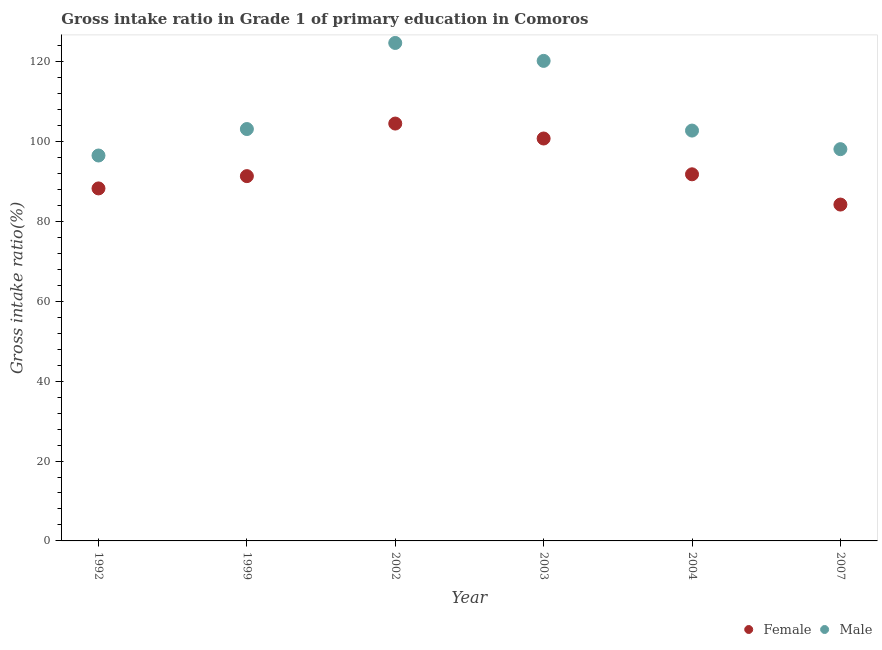What is the gross intake ratio(female) in 2007?
Provide a short and direct response. 84.2. Across all years, what is the maximum gross intake ratio(female)?
Provide a succinct answer. 104.48. Across all years, what is the minimum gross intake ratio(male)?
Give a very brief answer. 96.48. In which year was the gross intake ratio(male) maximum?
Your answer should be compact. 2002. In which year was the gross intake ratio(female) minimum?
Offer a terse response. 2007. What is the total gross intake ratio(female) in the graph?
Keep it short and to the point. 560.77. What is the difference between the gross intake ratio(female) in 2002 and that in 2004?
Provide a short and direct response. 12.7. What is the difference between the gross intake ratio(male) in 1999 and the gross intake ratio(female) in 2004?
Offer a very short reply. 11.33. What is the average gross intake ratio(male) per year?
Provide a succinct answer. 107.54. In the year 2004, what is the difference between the gross intake ratio(male) and gross intake ratio(female)?
Provide a succinct answer. 10.95. In how many years, is the gross intake ratio(female) greater than 72 %?
Keep it short and to the point. 6. What is the ratio of the gross intake ratio(female) in 1999 to that in 2004?
Make the answer very short. 1. Is the gross intake ratio(male) in 2002 less than that in 2007?
Your answer should be very brief. No. Is the difference between the gross intake ratio(female) in 2002 and 2003 greater than the difference between the gross intake ratio(male) in 2002 and 2003?
Offer a terse response. No. What is the difference between the highest and the second highest gross intake ratio(male)?
Your response must be concise. 4.49. What is the difference between the highest and the lowest gross intake ratio(male)?
Offer a terse response. 28.18. In how many years, is the gross intake ratio(female) greater than the average gross intake ratio(female) taken over all years?
Ensure brevity in your answer.  2. Is the sum of the gross intake ratio(female) in 1999 and 2007 greater than the maximum gross intake ratio(male) across all years?
Provide a succinct answer. Yes. Is the gross intake ratio(female) strictly greater than the gross intake ratio(male) over the years?
Your answer should be very brief. No. Is the gross intake ratio(male) strictly less than the gross intake ratio(female) over the years?
Keep it short and to the point. No. What is the difference between two consecutive major ticks on the Y-axis?
Your answer should be very brief. 20. Are the values on the major ticks of Y-axis written in scientific E-notation?
Provide a short and direct response. No. What is the title of the graph?
Provide a succinct answer. Gross intake ratio in Grade 1 of primary education in Comoros. Does "Primary" appear as one of the legend labels in the graph?
Your response must be concise. No. What is the label or title of the Y-axis?
Give a very brief answer. Gross intake ratio(%). What is the Gross intake ratio(%) of Female in 1992?
Your response must be concise. 88.25. What is the Gross intake ratio(%) of Male in 1992?
Your answer should be very brief. 96.48. What is the Gross intake ratio(%) in Female in 1999?
Make the answer very short. 91.32. What is the Gross intake ratio(%) in Male in 1999?
Your answer should be compact. 103.11. What is the Gross intake ratio(%) in Female in 2002?
Ensure brevity in your answer.  104.48. What is the Gross intake ratio(%) of Male in 2002?
Your answer should be very brief. 124.66. What is the Gross intake ratio(%) of Female in 2003?
Your response must be concise. 100.74. What is the Gross intake ratio(%) in Male in 2003?
Offer a very short reply. 120.17. What is the Gross intake ratio(%) of Female in 2004?
Make the answer very short. 91.78. What is the Gross intake ratio(%) of Male in 2004?
Provide a succinct answer. 102.73. What is the Gross intake ratio(%) of Female in 2007?
Your answer should be compact. 84.2. What is the Gross intake ratio(%) of Male in 2007?
Your answer should be compact. 98.07. Across all years, what is the maximum Gross intake ratio(%) of Female?
Provide a succinct answer. 104.48. Across all years, what is the maximum Gross intake ratio(%) in Male?
Your answer should be very brief. 124.66. Across all years, what is the minimum Gross intake ratio(%) in Female?
Offer a terse response. 84.2. Across all years, what is the minimum Gross intake ratio(%) in Male?
Your response must be concise. 96.48. What is the total Gross intake ratio(%) of Female in the graph?
Make the answer very short. 560.77. What is the total Gross intake ratio(%) of Male in the graph?
Your answer should be very brief. 645.23. What is the difference between the Gross intake ratio(%) of Female in 1992 and that in 1999?
Provide a short and direct response. -3.08. What is the difference between the Gross intake ratio(%) of Male in 1992 and that in 1999?
Offer a terse response. -6.63. What is the difference between the Gross intake ratio(%) in Female in 1992 and that in 2002?
Provide a succinct answer. -16.24. What is the difference between the Gross intake ratio(%) of Male in 1992 and that in 2002?
Your answer should be very brief. -28.18. What is the difference between the Gross intake ratio(%) in Female in 1992 and that in 2003?
Your answer should be compact. -12.49. What is the difference between the Gross intake ratio(%) of Male in 1992 and that in 2003?
Ensure brevity in your answer.  -23.69. What is the difference between the Gross intake ratio(%) in Female in 1992 and that in 2004?
Ensure brevity in your answer.  -3.53. What is the difference between the Gross intake ratio(%) in Male in 1992 and that in 2004?
Your answer should be very brief. -6.24. What is the difference between the Gross intake ratio(%) in Female in 1992 and that in 2007?
Your answer should be very brief. 4.04. What is the difference between the Gross intake ratio(%) in Male in 1992 and that in 2007?
Offer a very short reply. -1.59. What is the difference between the Gross intake ratio(%) of Female in 1999 and that in 2002?
Give a very brief answer. -13.16. What is the difference between the Gross intake ratio(%) of Male in 1999 and that in 2002?
Ensure brevity in your answer.  -21.55. What is the difference between the Gross intake ratio(%) in Female in 1999 and that in 2003?
Your response must be concise. -9.42. What is the difference between the Gross intake ratio(%) of Male in 1999 and that in 2003?
Ensure brevity in your answer.  -17.06. What is the difference between the Gross intake ratio(%) in Female in 1999 and that in 2004?
Ensure brevity in your answer.  -0.46. What is the difference between the Gross intake ratio(%) in Male in 1999 and that in 2004?
Ensure brevity in your answer.  0.38. What is the difference between the Gross intake ratio(%) of Female in 1999 and that in 2007?
Offer a terse response. 7.12. What is the difference between the Gross intake ratio(%) of Male in 1999 and that in 2007?
Offer a terse response. 5.04. What is the difference between the Gross intake ratio(%) of Female in 2002 and that in 2003?
Keep it short and to the point. 3.74. What is the difference between the Gross intake ratio(%) in Male in 2002 and that in 2003?
Make the answer very short. 4.49. What is the difference between the Gross intake ratio(%) in Female in 2002 and that in 2004?
Your response must be concise. 12.7. What is the difference between the Gross intake ratio(%) in Male in 2002 and that in 2004?
Offer a terse response. 21.93. What is the difference between the Gross intake ratio(%) of Female in 2002 and that in 2007?
Provide a short and direct response. 20.28. What is the difference between the Gross intake ratio(%) of Male in 2002 and that in 2007?
Your response must be concise. 26.59. What is the difference between the Gross intake ratio(%) of Female in 2003 and that in 2004?
Your answer should be compact. 8.96. What is the difference between the Gross intake ratio(%) of Male in 2003 and that in 2004?
Your answer should be compact. 17.45. What is the difference between the Gross intake ratio(%) of Female in 2003 and that in 2007?
Make the answer very short. 16.54. What is the difference between the Gross intake ratio(%) of Male in 2003 and that in 2007?
Your response must be concise. 22.1. What is the difference between the Gross intake ratio(%) in Female in 2004 and that in 2007?
Keep it short and to the point. 7.58. What is the difference between the Gross intake ratio(%) in Male in 2004 and that in 2007?
Ensure brevity in your answer.  4.65. What is the difference between the Gross intake ratio(%) of Female in 1992 and the Gross intake ratio(%) of Male in 1999?
Your answer should be compact. -14.86. What is the difference between the Gross intake ratio(%) in Female in 1992 and the Gross intake ratio(%) in Male in 2002?
Your answer should be compact. -36.42. What is the difference between the Gross intake ratio(%) of Female in 1992 and the Gross intake ratio(%) of Male in 2003?
Your response must be concise. -31.93. What is the difference between the Gross intake ratio(%) in Female in 1992 and the Gross intake ratio(%) in Male in 2004?
Give a very brief answer. -14.48. What is the difference between the Gross intake ratio(%) in Female in 1992 and the Gross intake ratio(%) in Male in 2007?
Your answer should be very brief. -9.83. What is the difference between the Gross intake ratio(%) in Female in 1999 and the Gross intake ratio(%) in Male in 2002?
Give a very brief answer. -33.34. What is the difference between the Gross intake ratio(%) of Female in 1999 and the Gross intake ratio(%) of Male in 2003?
Ensure brevity in your answer.  -28.85. What is the difference between the Gross intake ratio(%) of Female in 1999 and the Gross intake ratio(%) of Male in 2004?
Offer a terse response. -11.4. What is the difference between the Gross intake ratio(%) in Female in 1999 and the Gross intake ratio(%) in Male in 2007?
Keep it short and to the point. -6.75. What is the difference between the Gross intake ratio(%) in Female in 2002 and the Gross intake ratio(%) in Male in 2003?
Your answer should be very brief. -15.69. What is the difference between the Gross intake ratio(%) in Female in 2002 and the Gross intake ratio(%) in Male in 2004?
Make the answer very short. 1.76. What is the difference between the Gross intake ratio(%) in Female in 2002 and the Gross intake ratio(%) in Male in 2007?
Offer a very short reply. 6.41. What is the difference between the Gross intake ratio(%) in Female in 2003 and the Gross intake ratio(%) in Male in 2004?
Keep it short and to the point. -1.99. What is the difference between the Gross intake ratio(%) in Female in 2003 and the Gross intake ratio(%) in Male in 2007?
Offer a terse response. 2.67. What is the difference between the Gross intake ratio(%) in Female in 2004 and the Gross intake ratio(%) in Male in 2007?
Your response must be concise. -6.29. What is the average Gross intake ratio(%) in Female per year?
Provide a short and direct response. 93.46. What is the average Gross intake ratio(%) of Male per year?
Your answer should be compact. 107.54. In the year 1992, what is the difference between the Gross intake ratio(%) of Female and Gross intake ratio(%) of Male?
Offer a terse response. -8.24. In the year 1999, what is the difference between the Gross intake ratio(%) of Female and Gross intake ratio(%) of Male?
Ensure brevity in your answer.  -11.79. In the year 2002, what is the difference between the Gross intake ratio(%) in Female and Gross intake ratio(%) in Male?
Your answer should be compact. -20.18. In the year 2003, what is the difference between the Gross intake ratio(%) in Female and Gross intake ratio(%) in Male?
Provide a short and direct response. -19.43. In the year 2004, what is the difference between the Gross intake ratio(%) of Female and Gross intake ratio(%) of Male?
Offer a very short reply. -10.95. In the year 2007, what is the difference between the Gross intake ratio(%) of Female and Gross intake ratio(%) of Male?
Provide a short and direct response. -13.87. What is the ratio of the Gross intake ratio(%) of Female in 1992 to that in 1999?
Give a very brief answer. 0.97. What is the ratio of the Gross intake ratio(%) of Male in 1992 to that in 1999?
Offer a very short reply. 0.94. What is the ratio of the Gross intake ratio(%) of Female in 1992 to that in 2002?
Ensure brevity in your answer.  0.84. What is the ratio of the Gross intake ratio(%) of Male in 1992 to that in 2002?
Your answer should be very brief. 0.77. What is the ratio of the Gross intake ratio(%) in Female in 1992 to that in 2003?
Your answer should be compact. 0.88. What is the ratio of the Gross intake ratio(%) in Male in 1992 to that in 2003?
Offer a terse response. 0.8. What is the ratio of the Gross intake ratio(%) of Female in 1992 to that in 2004?
Offer a terse response. 0.96. What is the ratio of the Gross intake ratio(%) in Male in 1992 to that in 2004?
Keep it short and to the point. 0.94. What is the ratio of the Gross intake ratio(%) of Female in 1992 to that in 2007?
Your answer should be compact. 1.05. What is the ratio of the Gross intake ratio(%) in Male in 1992 to that in 2007?
Provide a short and direct response. 0.98. What is the ratio of the Gross intake ratio(%) of Female in 1999 to that in 2002?
Provide a short and direct response. 0.87. What is the ratio of the Gross intake ratio(%) in Male in 1999 to that in 2002?
Your response must be concise. 0.83. What is the ratio of the Gross intake ratio(%) of Female in 1999 to that in 2003?
Provide a short and direct response. 0.91. What is the ratio of the Gross intake ratio(%) in Male in 1999 to that in 2003?
Your response must be concise. 0.86. What is the ratio of the Gross intake ratio(%) of Female in 1999 to that in 2004?
Your answer should be very brief. 0.99. What is the ratio of the Gross intake ratio(%) in Male in 1999 to that in 2004?
Make the answer very short. 1. What is the ratio of the Gross intake ratio(%) of Female in 1999 to that in 2007?
Offer a very short reply. 1.08. What is the ratio of the Gross intake ratio(%) in Male in 1999 to that in 2007?
Ensure brevity in your answer.  1.05. What is the ratio of the Gross intake ratio(%) in Female in 2002 to that in 2003?
Keep it short and to the point. 1.04. What is the ratio of the Gross intake ratio(%) in Male in 2002 to that in 2003?
Offer a very short reply. 1.04. What is the ratio of the Gross intake ratio(%) in Female in 2002 to that in 2004?
Ensure brevity in your answer.  1.14. What is the ratio of the Gross intake ratio(%) of Male in 2002 to that in 2004?
Provide a short and direct response. 1.21. What is the ratio of the Gross intake ratio(%) of Female in 2002 to that in 2007?
Keep it short and to the point. 1.24. What is the ratio of the Gross intake ratio(%) of Male in 2002 to that in 2007?
Your answer should be very brief. 1.27. What is the ratio of the Gross intake ratio(%) of Female in 2003 to that in 2004?
Your answer should be compact. 1.1. What is the ratio of the Gross intake ratio(%) in Male in 2003 to that in 2004?
Ensure brevity in your answer.  1.17. What is the ratio of the Gross intake ratio(%) in Female in 2003 to that in 2007?
Your answer should be compact. 1.2. What is the ratio of the Gross intake ratio(%) in Male in 2003 to that in 2007?
Your answer should be compact. 1.23. What is the ratio of the Gross intake ratio(%) of Female in 2004 to that in 2007?
Your answer should be very brief. 1.09. What is the ratio of the Gross intake ratio(%) in Male in 2004 to that in 2007?
Make the answer very short. 1.05. What is the difference between the highest and the second highest Gross intake ratio(%) of Female?
Offer a very short reply. 3.74. What is the difference between the highest and the second highest Gross intake ratio(%) in Male?
Offer a very short reply. 4.49. What is the difference between the highest and the lowest Gross intake ratio(%) of Female?
Keep it short and to the point. 20.28. What is the difference between the highest and the lowest Gross intake ratio(%) of Male?
Your answer should be compact. 28.18. 